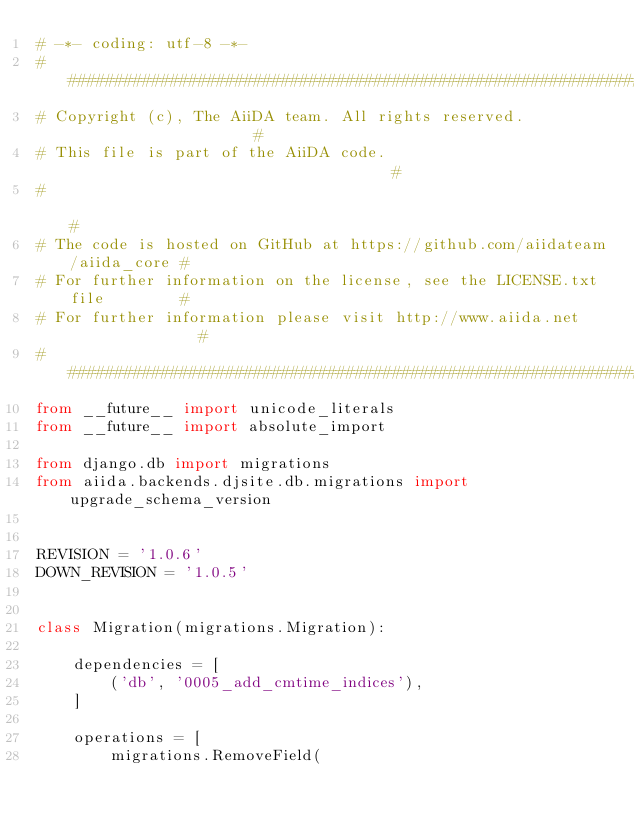<code> <loc_0><loc_0><loc_500><loc_500><_Python_># -*- coding: utf-8 -*-
###########################################################################
# Copyright (c), The AiiDA team. All rights reserved.                     #
# This file is part of the AiiDA code.                                    #
#                                                                         #
# The code is hosted on GitHub at https://github.com/aiidateam/aiida_core #
# For further information on the license, see the LICENSE.txt file        #
# For further information please visit http://www.aiida.net               #
###########################################################################
from __future__ import unicode_literals
from __future__ import absolute_import

from django.db import migrations
from aiida.backends.djsite.db.migrations import upgrade_schema_version


REVISION = '1.0.6'
DOWN_REVISION = '1.0.5'


class Migration(migrations.Migration):

    dependencies = [
        ('db', '0005_add_cmtime_indices'),
    ]

    operations = [
        migrations.RemoveField(</code> 